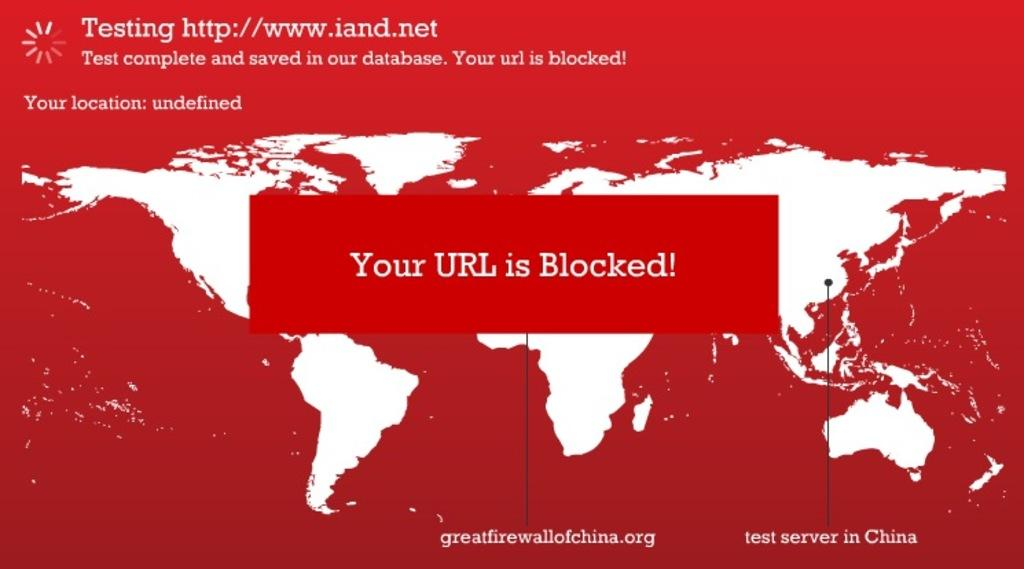<image>
Create a compact narrative representing the image presented. a red background with a URL blocked message 